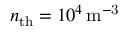Convert formula to latex. <formula><loc_0><loc_0><loc_500><loc_500>n _ { t h } = 1 0 ^ { 4 } \, m ^ { - 3 }</formula> 